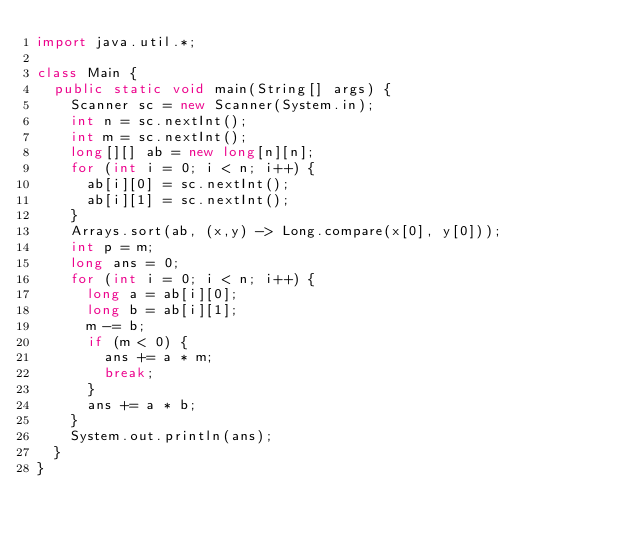Convert code to text. <code><loc_0><loc_0><loc_500><loc_500><_Java_>import java.util.*;

class Main {
  public static void main(String[] args) {
    Scanner sc = new Scanner(System.in);
    int n = sc.nextInt();
    int m = sc.nextInt();
    long[][] ab = new long[n][n];
    for (int i = 0; i < n; i++) {
      ab[i][0] = sc.nextInt();
      ab[i][1] = sc.nextInt();
    }
    Arrays.sort(ab, (x,y) -> Long.compare(x[0], y[0]));
    int p = m;
    long ans = 0;
    for (int i = 0; i < n; i++) {
      long a = ab[i][0];
      long b = ab[i][1];
      m -= b;
      if (m < 0) {
        ans += a * m;
        break;
      }
      ans += a * b;
    }
    System.out.println(ans);
  }
}</code> 